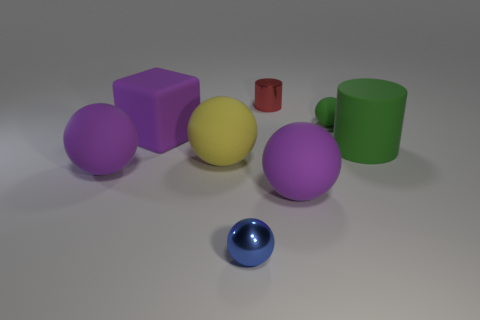There is a object that is in front of the rubber block and behind the large yellow rubber ball; what is its color?
Ensure brevity in your answer.  Green. There is a purple rubber sphere that is to the right of the matte block; is it the same size as the big yellow matte object?
Make the answer very short. Yes. What number of objects are either large objects on the left side of the purple rubber cube or red things?
Provide a short and direct response. 2. Are there any purple objects of the same size as the green matte cylinder?
Offer a very short reply. Yes. What material is the blue ball that is the same size as the red thing?
Offer a very short reply. Metal. There is a purple matte object that is both in front of the big green thing and left of the tiny red metal cylinder; what is its shape?
Provide a succinct answer. Sphere. There is a matte ball behind the big yellow rubber thing; what is its color?
Your answer should be very brief. Green. There is a matte sphere that is both right of the small blue object and in front of the large green cylinder; what is its size?
Your answer should be very brief. Large. Are the big cylinder and the big purple sphere to the left of the big yellow ball made of the same material?
Your answer should be very brief. Yes. How many other big things are the same shape as the yellow object?
Your answer should be very brief. 2. 